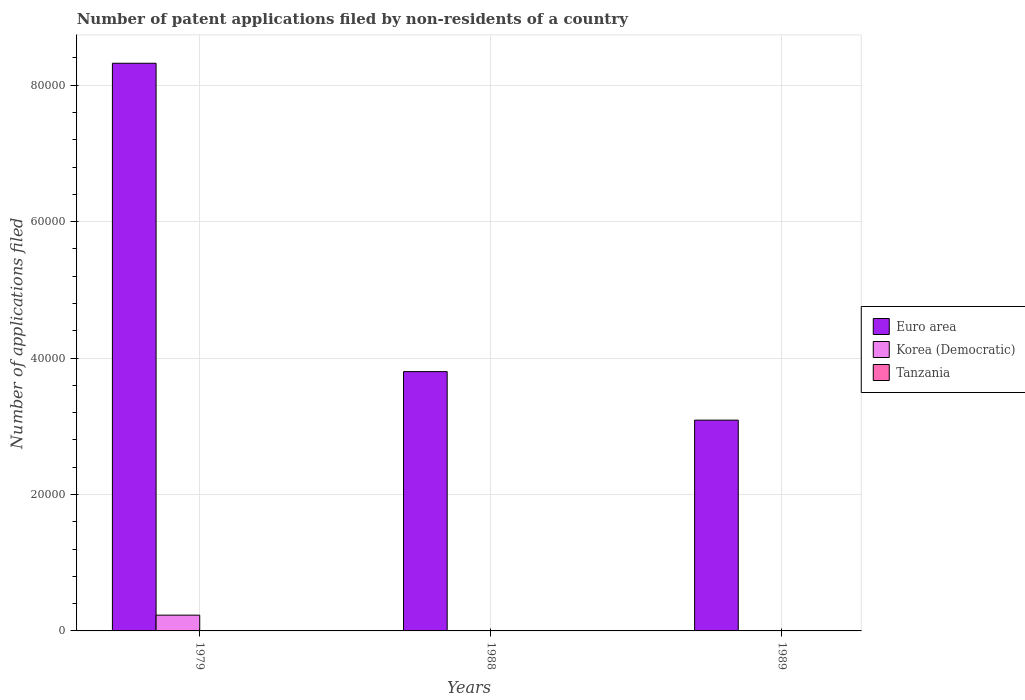How many groups of bars are there?
Make the answer very short. 3. How many bars are there on the 1st tick from the left?
Make the answer very short. 3. What is the label of the 2nd group of bars from the left?
Your response must be concise. 1988. What is the number of applications filed in Korea (Democratic) in 1979?
Your answer should be very brief. 2312. Across all years, what is the maximum number of applications filed in Euro area?
Provide a succinct answer. 8.32e+04. Across all years, what is the minimum number of applications filed in Euro area?
Offer a very short reply. 3.09e+04. In which year was the number of applications filed in Korea (Democratic) maximum?
Offer a terse response. 1979. What is the total number of applications filed in Euro area in the graph?
Offer a very short reply. 1.52e+05. What is the difference between the number of applications filed in Euro area in 1988 and that in 1989?
Make the answer very short. 7113. What is the difference between the number of applications filed in Euro area in 1988 and the number of applications filed in Tanzania in 1989?
Offer a terse response. 3.80e+04. What is the average number of applications filed in Korea (Democratic) per year?
Your answer should be compact. 779.33. In the year 1988, what is the difference between the number of applications filed in Tanzania and number of applications filed in Korea (Democratic)?
Your answer should be very brief. 24. In how many years, is the number of applications filed in Euro area greater than 48000?
Keep it short and to the point. 1. What is the ratio of the number of applications filed in Tanzania in 1979 to that in 1989?
Your answer should be very brief. 1.83. Is the number of applications filed in Korea (Democratic) in 1979 less than that in 1989?
Provide a short and direct response. No. What is the difference between the highest and the lowest number of applications filed in Korea (Democratic)?
Make the answer very short. 2299. What does the 2nd bar from the right in 1979 represents?
Provide a short and direct response. Korea (Democratic). Is it the case that in every year, the sum of the number of applications filed in Tanzania and number of applications filed in Euro area is greater than the number of applications filed in Korea (Democratic)?
Provide a succinct answer. Yes. How many bars are there?
Provide a succinct answer. 9. Are the values on the major ticks of Y-axis written in scientific E-notation?
Offer a terse response. No. Does the graph contain any zero values?
Provide a succinct answer. No. Does the graph contain grids?
Provide a succinct answer. Yes. Where does the legend appear in the graph?
Provide a short and direct response. Center right. How are the legend labels stacked?
Your response must be concise. Vertical. What is the title of the graph?
Offer a very short reply. Number of patent applications filed by non-residents of a country. Does "Micronesia" appear as one of the legend labels in the graph?
Ensure brevity in your answer.  No. What is the label or title of the X-axis?
Your answer should be very brief. Years. What is the label or title of the Y-axis?
Offer a terse response. Number of applications filed. What is the Number of applications filed in Euro area in 1979?
Offer a terse response. 8.32e+04. What is the Number of applications filed in Korea (Democratic) in 1979?
Your answer should be compact. 2312. What is the Number of applications filed of Euro area in 1988?
Give a very brief answer. 3.80e+04. What is the Number of applications filed in Euro area in 1989?
Keep it short and to the point. 3.09e+04. What is the Number of applications filed of Tanzania in 1989?
Your response must be concise. 23. Across all years, what is the maximum Number of applications filed of Euro area?
Offer a terse response. 8.32e+04. Across all years, what is the maximum Number of applications filed of Korea (Democratic)?
Offer a terse response. 2312. Across all years, what is the maximum Number of applications filed in Tanzania?
Provide a succinct answer. 42. Across all years, what is the minimum Number of applications filed of Euro area?
Offer a terse response. 3.09e+04. Across all years, what is the minimum Number of applications filed in Korea (Democratic)?
Make the answer very short. 13. What is the total Number of applications filed of Euro area in the graph?
Make the answer very short. 1.52e+05. What is the total Number of applications filed in Korea (Democratic) in the graph?
Provide a succinct answer. 2338. What is the total Number of applications filed of Tanzania in the graph?
Your response must be concise. 102. What is the difference between the Number of applications filed in Euro area in 1979 and that in 1988?
Provide a succinct answer. 4.52e+04. What is the difference between the Number of applications filed of Korea (Democratic) in 1979 and that in 1988?
Offer a terse response. 2299. What is the difference between the Number of applications filed in Tanzania in 1979 and that in 1988?
Make the answer very short. 5. What is the difference between the Number of applications filed in Euro area in 1979 and that in 1989?
Keep it short and to the point. 5.23e+04. What is the difference between the Number of applications filed in Korea (Democratic) in 1979 and that in 1989?
Give a very brief answer. 2299. What is the difference between the Number of applications filed in Tanzania in 1979 and that in 1989?
Your response must be concise. 19. What is the difference between the Number of applications filed in Euro area in 1988 and that in 1989?
Your answer should be compact. 7113. What is the difference between the Number of applications filed of Tanzania in 1988 and that in 1989?
Give a very brief answer. 14. What is the difference between the Number of applications filed in Euro area in 1979 and the Number of applications filed in Korea (Democratic) in 1988?
Provide a short and direct response. 8.32e+04. What is the difference between the Number of applications filed of Euro area in 1979 and the Number of applications filed of Tanzania in 1988?
Keep it short and to the point. 8.32e+04. What is the difference between the Number of applications filed of Korea (Democratic) in 1979 and the Number of applications filed of Tanzania in 1988?
Provide a short and direct response. 2275. What is the difference between the Number of applications filed in Euro area in 1979 and the Number of applications filed in Korea (Democratic) in 1989?
Make the answer very short. 8.32e+04. What is the difference between the Number of applications filed in Euro area in 1979 and the Number of applications filed in Tanzania in 1989?
Keep it short and to the point. 8.32e+04. What is the difference between the Number of applications filed of Korea (Democratic) in 1979 and the Number of applications filed of Tanzania in 1989?
Make the answer very short. 2289. What is the difference between the Number of applications filed of Euro area in 1988 and the Number of applications filed of Korea (Democratic) in 1989?
Provide a short and direct response. 3.80e+04. What is the difference between the Number of applications filed of Euro area in 1988 and the Number of applications filed of Tanzania in 1989?
Offer a very short reply. 3.80e+04. What is the average Number of applications filed in Euro area per year?
Ensure brevity in your answer.  5.07e+04. What is the average Number of applications filed of Korea (Democratic) per year?
Provide a succinct answer. 779.33. What is the average Number of applications filed in Tanzania per year?
Ensure brevity in your answer.  34. In the year 1979, what is the difference between the Number of applications filed in Euro area and Number of applications filed in Korea (Democratic)?
Your answer should be very brief. 8.09e+04. In the year 1979, what is the difference between the Number of applications filed of Euro area and Number of applications filed of Tanzania?
Your response must be concise. 8.32e+04. In the year 1979, what is the difference between the Number of applications filed of Korea (Democratic) and Number of applications filed of Tanzania?
Make the answer very short. 2270. In the year 1988, what is the difference between the Number of applications filed of Euro area and Number of applications filed of Korea (Democratic)?
Provide a succinct answer. 3.80e+04. In the year 1988, what is the difference between the Number of applications filed in Euro area and Number of applications filed in Tanzania?
Offer a terse response. 3.80e+04. In the year 1988, what is the difference between the Number of applications filed in Korea (Democratic) and Number of applications filed in Tanzania?
Your answer should be compact. -24. In the year 1989, what is the difference between the Number of applications filed in Euro area and Number of applications filed in Korea (Democratic)?
Offer a terse response. 3.09e+04. In the year 1989, what is the difference between the Number of applications filed in Euro area and Number of applications filed in Tanzania?
Make the answer very short. 3.09e+04. What is the ratio of the Number of applications filed of Euro area in 1979 to that in 1988?
Give a very brief answer. 2.19. What is the ratio of the Number of applications filed of Korea (Democratic) in 1979 to that in 1988?
Give a very brief answer. 177.85. What is the ratio of the Number of applications filed of Tanzania in 1979 to that in 1988?
Offer a very short reply. 1.14. What is the ratio of the Number of applications filed in Euro area in 1979 to that in 1989?
Make the answer very short. 2.69. What is the ratio of the Number of applications filed in Korea (Democratic) in 1979 to that in 1989?
Your answer should be compact. 177.85. What is the ratio of the Number of applications filed in Tanzania in 1979 to that in 1989?
Your response must be concise. 1.83. What is the ratio of the Number of applications filed in Euro area in 1988 to that in 1989?
Your response must be concise. 1.23. What is the ratio of the Number of applications filed of Tanzania in 1988 to that in 1989?
Give a very brief answer. 1.61. What is the difference between the highest and the second highest Number of applications filed of Euro area?
Keep it short and to the point. 4.52e+04. What is the difference between the highest and the second highest Number of applications filed in Korea (Democratic)?
Your answer should be compact. 2299. What is the difference between the highest and the lowest Number of applications filed of Euro area?
Provide a short and direct response. 5.23e+04. What is the difference between the highest and the lowest Number of applications filed in Korea (Democratic)?
Offer a terse response. 2299. What is the difference between the highest and the lowest Number of applications filed in Tanzania?
Your answer should be very brief. 19. 